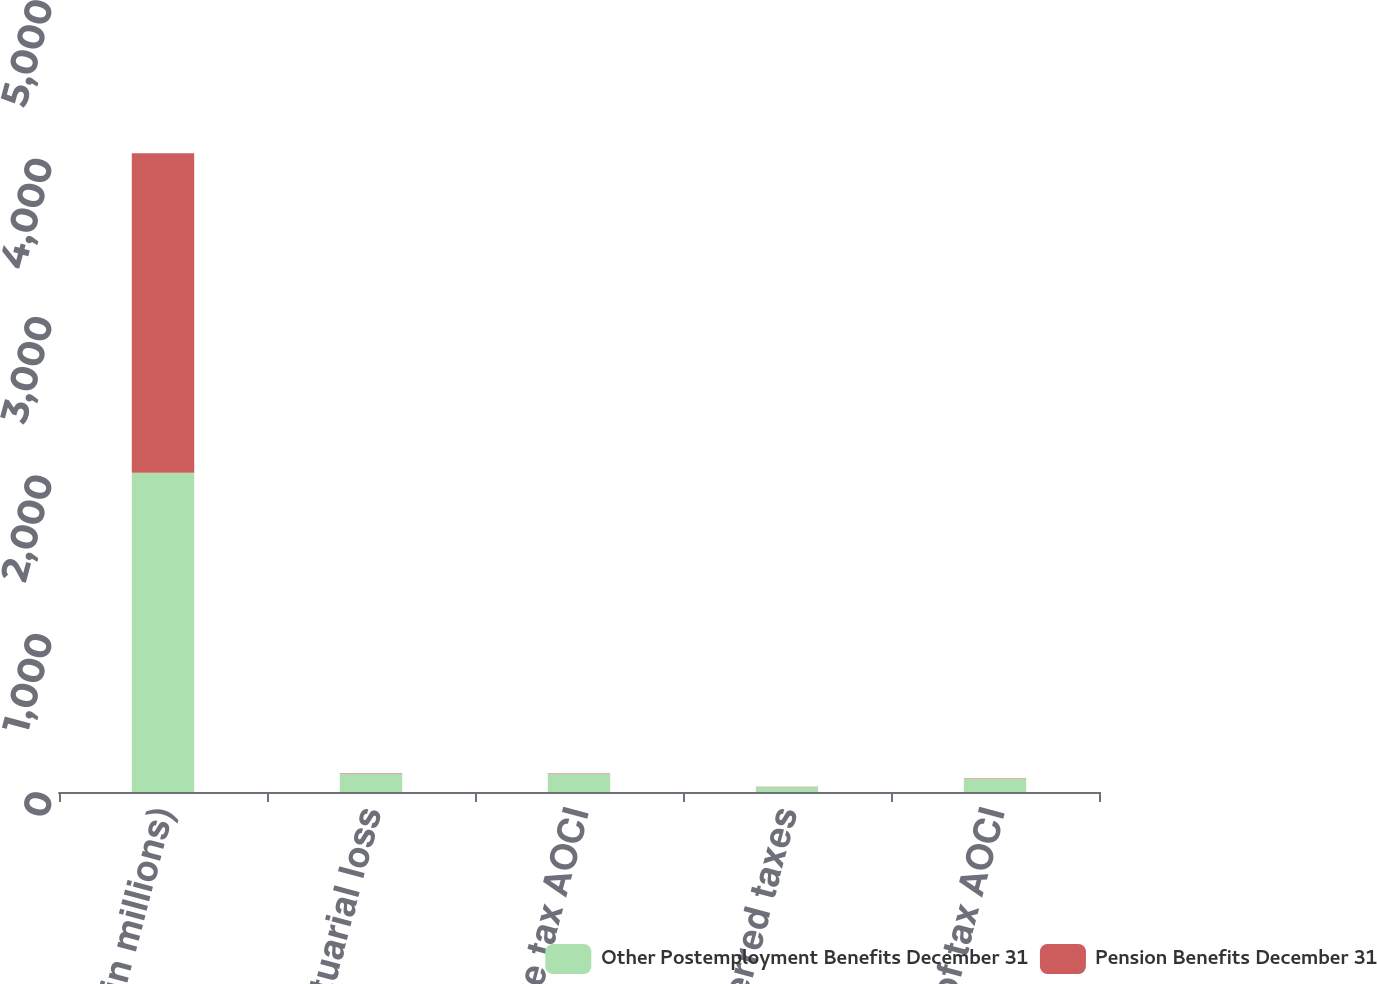Convert chart. <chart><loc_0><loc_0><loc_500><loc_500><stacked_bar_chart><ecel><fcel>(in millions)<fcel>Net actuarial loss<fcel>Before tax AOCI<fcel>Less Deferred taxes<fcel>Net of tax AOCI<nl><fcel>Other Postemployment Benefits December 31<fcel>2016<fcel>115.3<fcel>113.5<fcel>31.2<fcel>82.3<nl><fcel>Pension Benefits December 31<fcel>2016<fcel>3.5<fcel>3.5<fcel>1.3<fcel>2.2<nl></chart> 